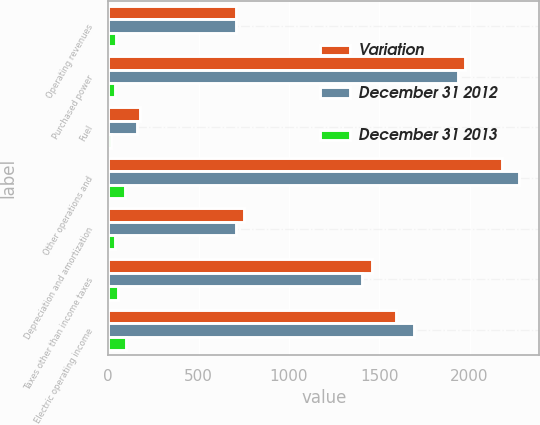<chart> <loc_0><loc_0><loc_500><loc_500><stacked_bar_chart><ecel><fcel>Operating revenues<fcel>Purchased power<fcel>Fuel<fcel>Other operations and<fcel>Depreciation and amortization<fcel>Taxes other than income taxes<fcel>Electric operating income<nl><fcel>Variation<fcel>710<fcel>1974<fcel>174<fcel>2180<fcel>749<fcel>1459<fcel>1595<nl><fcel>December 31 2012<fcel>710<fcel>1938<fcel>159<fcel>2273<fcel>710<fcel>1403<fcel>1693<nl><fcel>December 31 2013<fcel>45<fcel>36<fcel>15<fcel>93<fcel>39<fcel>56<fcel>98<nl></chart> 